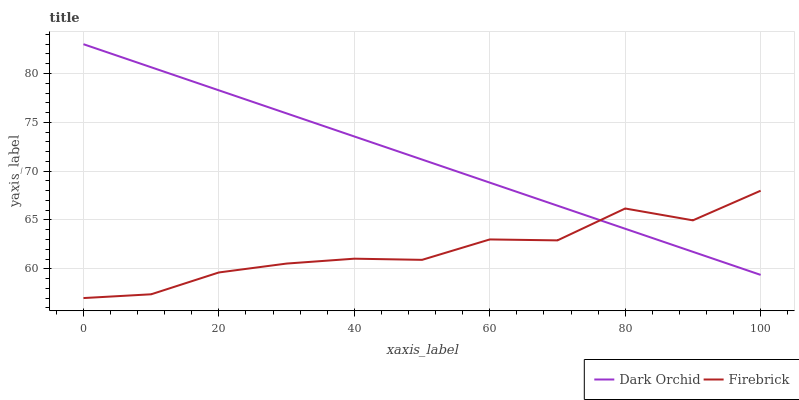Does Firebrick have the minimum area under the curve?
Answer yes or no. Yes. Does Dark Orchid have the maximum area under the curve?
Answer yes or no. Yes. Does Dark Orchid have the minimum area under the curve?
Answer yes or no. No. Is Dark Orchid the smoothest?
Answer yes or no. Yes. Is Firebrick the roughest?
Answer yes or no. Yes. Is Dark Orchid the roughest?
Answer yes or no. No. Does Firebrick have the lowest value?
Answer yes or no. Yes. Does Dark Orchid have the lowest value?
Answer yes or no. No. Does Dark Orchid have the highest value?
Answer yes or no. Yes. Does Dark Orchid intersect Firebrick?
Answer yes or no. Yes. Is Dark Orchid less than Firebrick?
Answer yes or no. No. Is Dark Orchid greater than Firebrick?
Answer yes or no. No. 